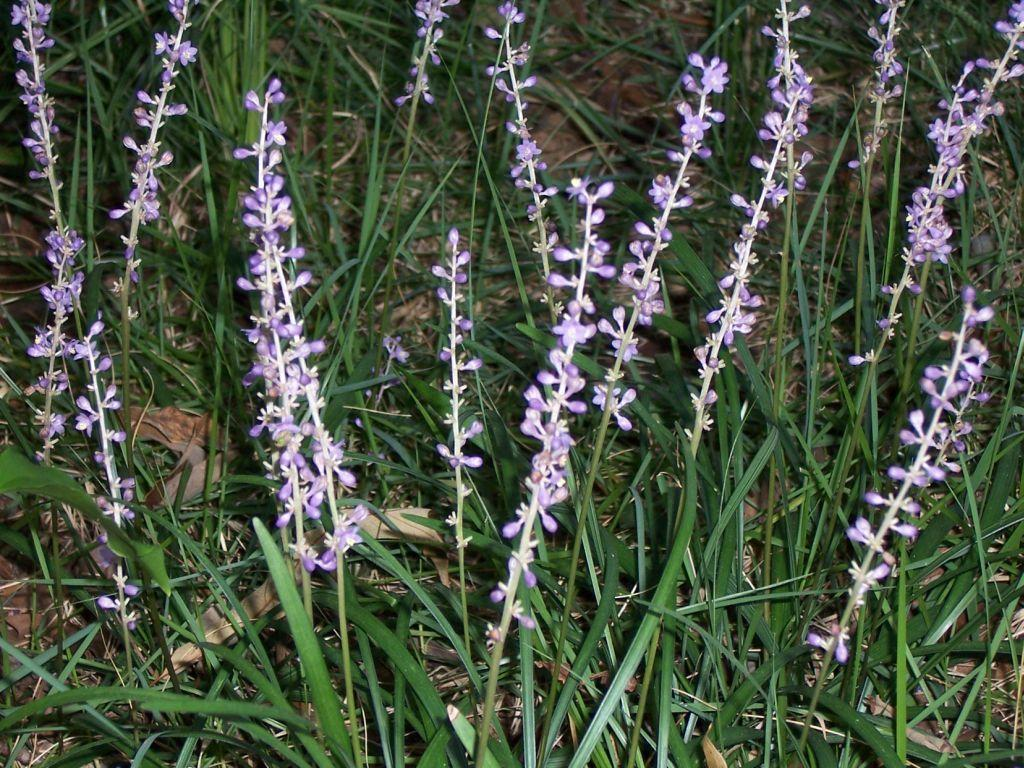What type of vegetation can be seen in the image? There is grass, plants, and flowers in the image. What colors are the flowers in the image? The flowers are violet and white in color. What part of the natural environment is visible in the image? The ground is visible in the image. Can you tell me how many dolls are swimming in the image? There are no dolls or swimming activity present in the image. 